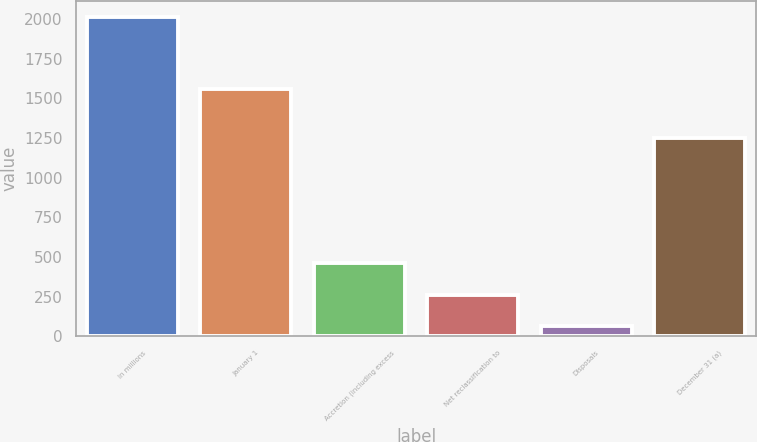<chart> <loc_0><loc_0><loc_500><loc_500><bar_chart><fcel>In millions<fcel>January 1<fcel>Accretion (including excess<fcel>Net reclassification to<fcel>Disposals<fcel>December 31 (a)<nl><fcel>2015<fcel>1558<fcel>466<fcel>262.7<fcel>68<fcel>1250<nl></chart> 